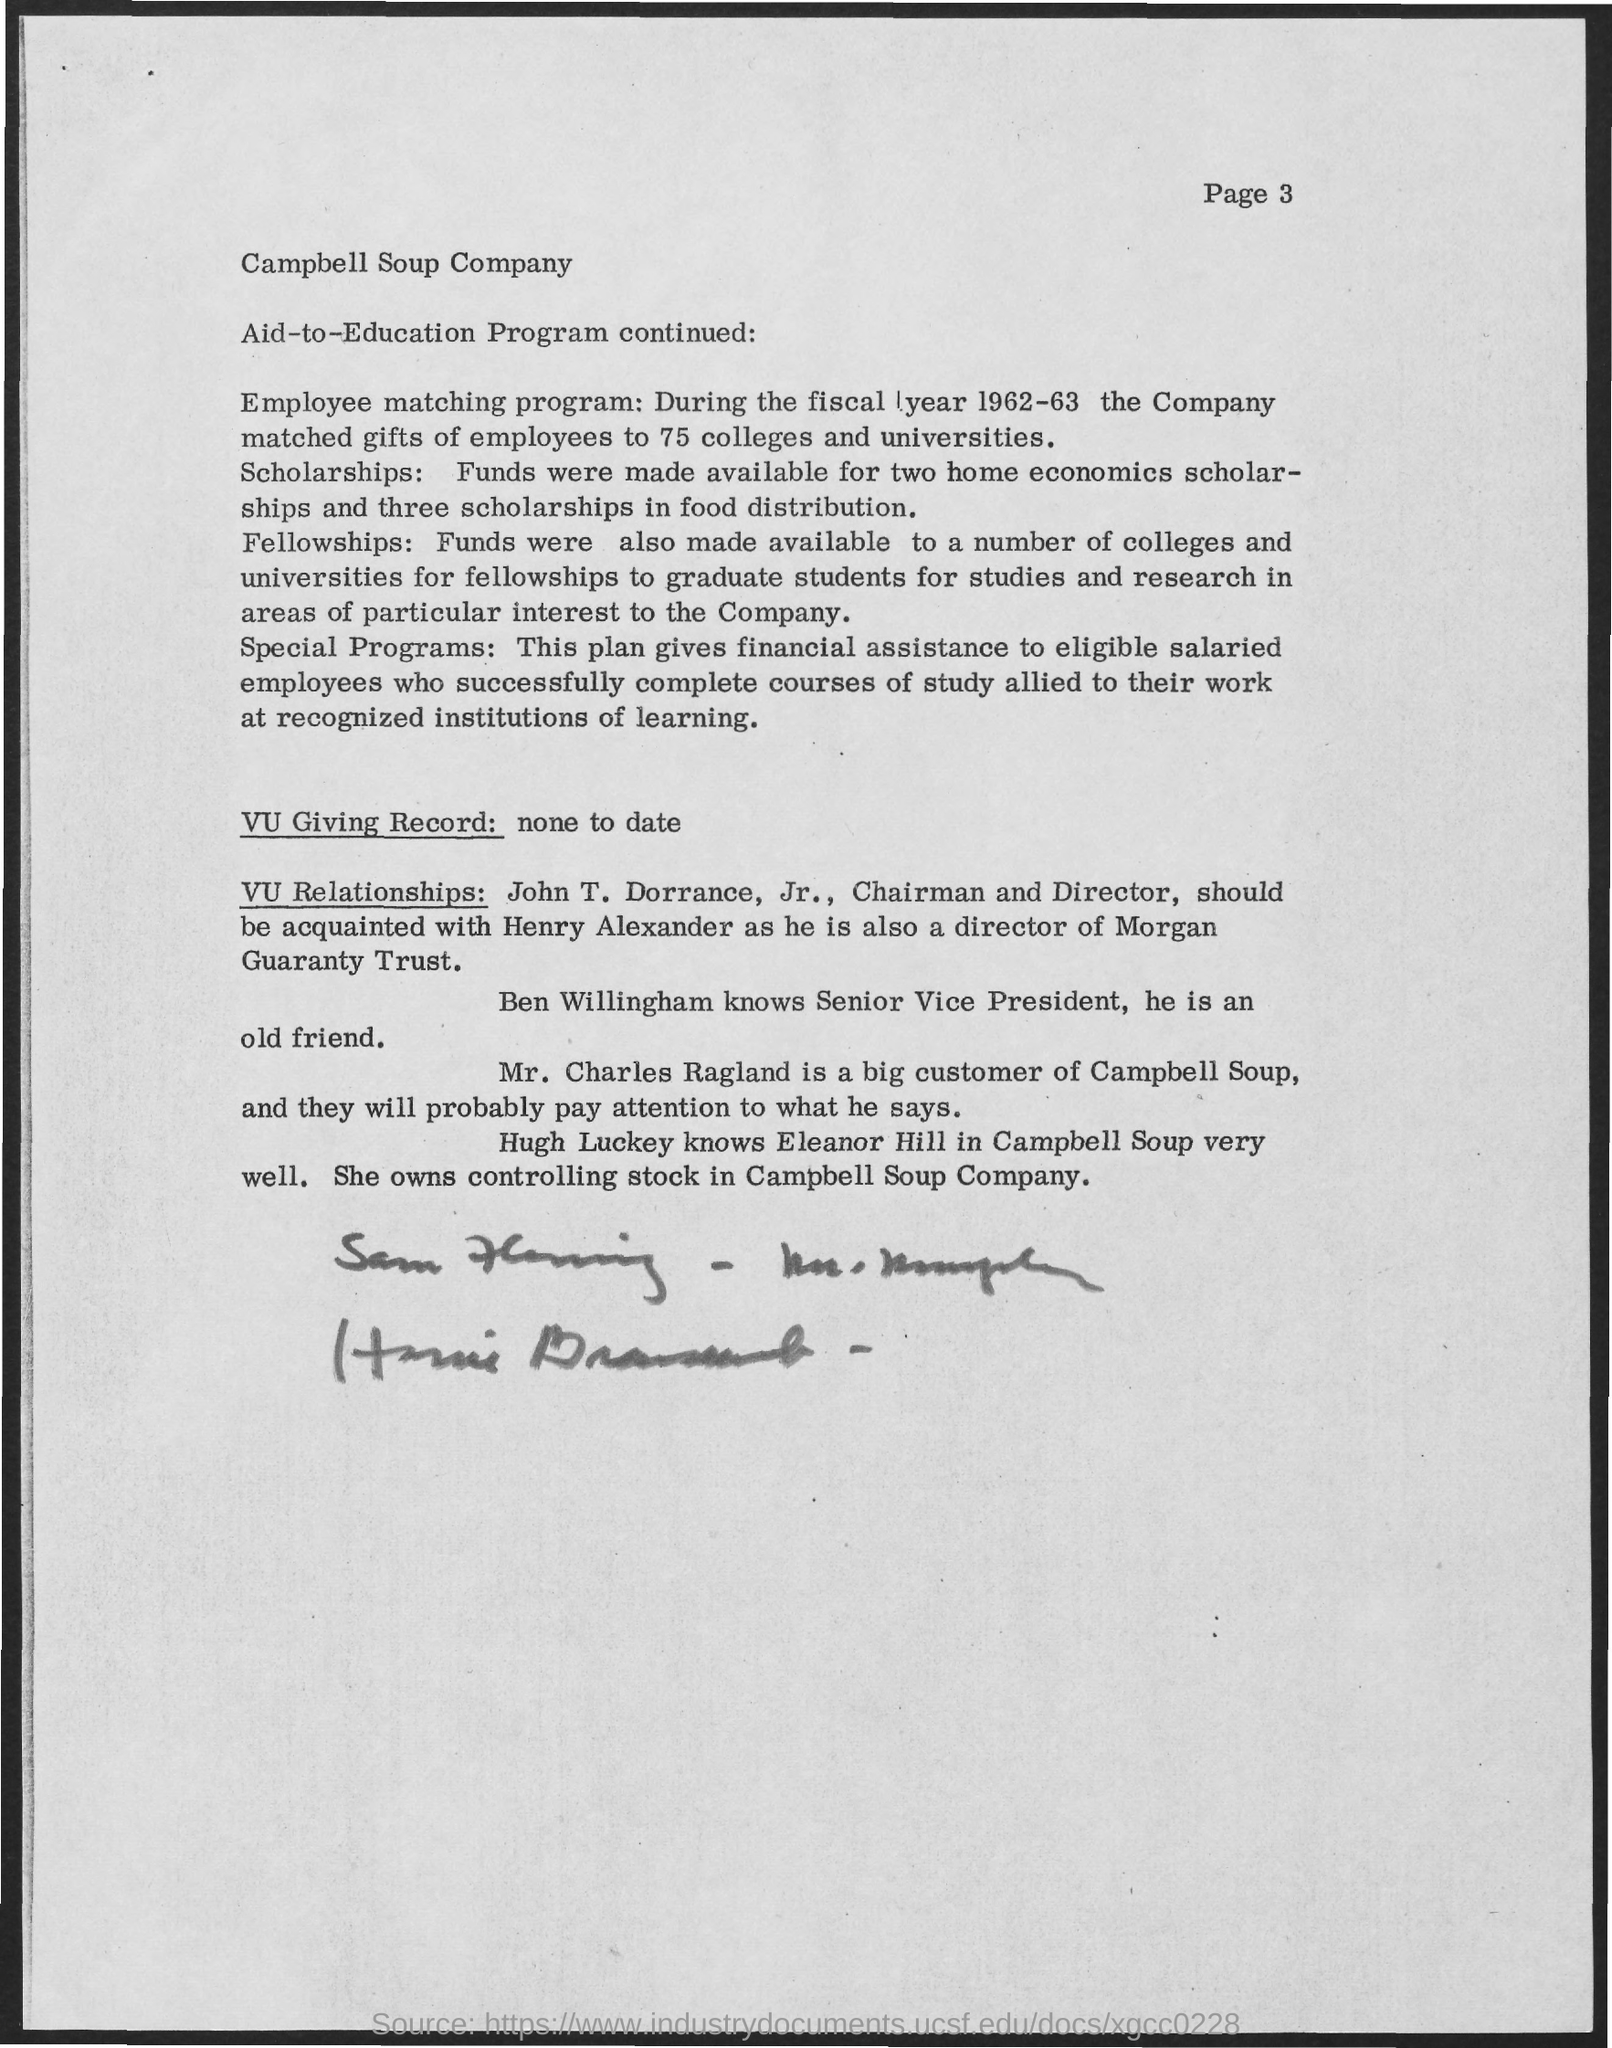What is the Page Number?
Your answer should be very brief. Page 3. Who is a Big customer of Campbell Soup?
Make the answer very short. Mr. Charles Ragland. 